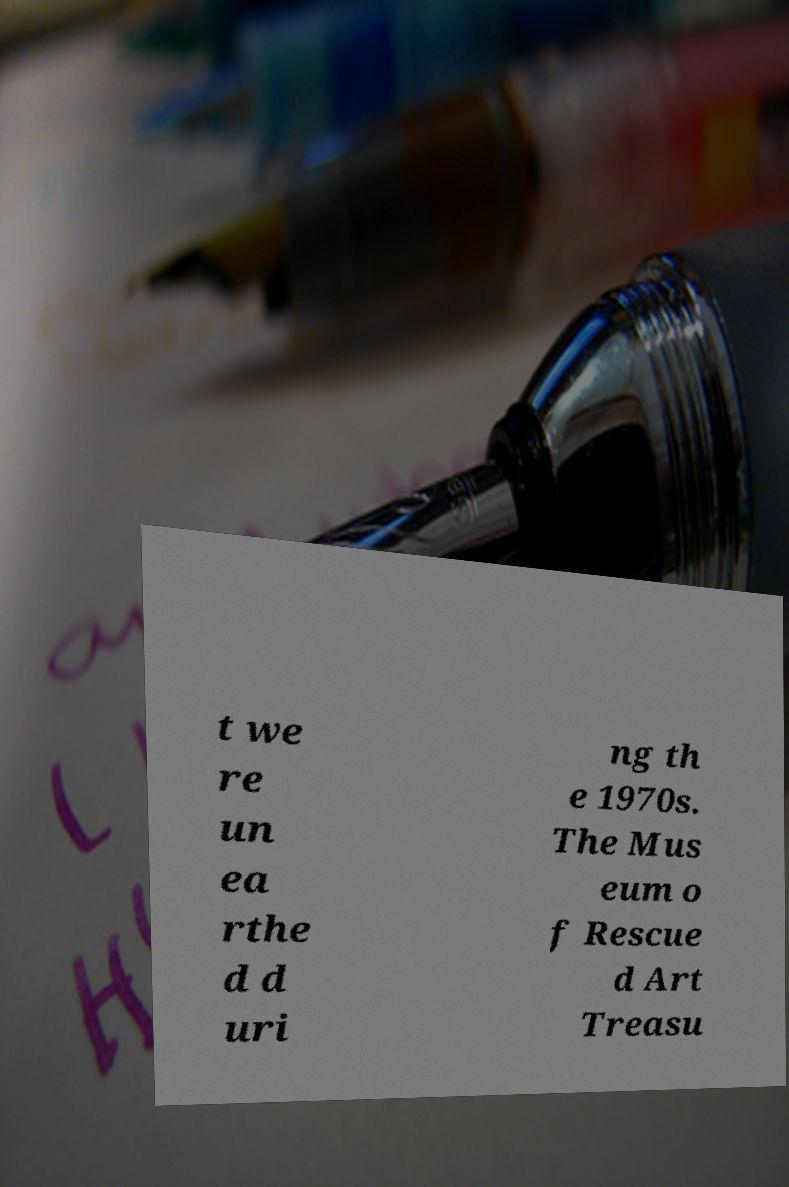What messages or text are displayed in this image? I need them in a readable, typed format. t we re un ea rthe d d uri ng th e 1970s. The Mus eum o f Rescue d Art Treasu 